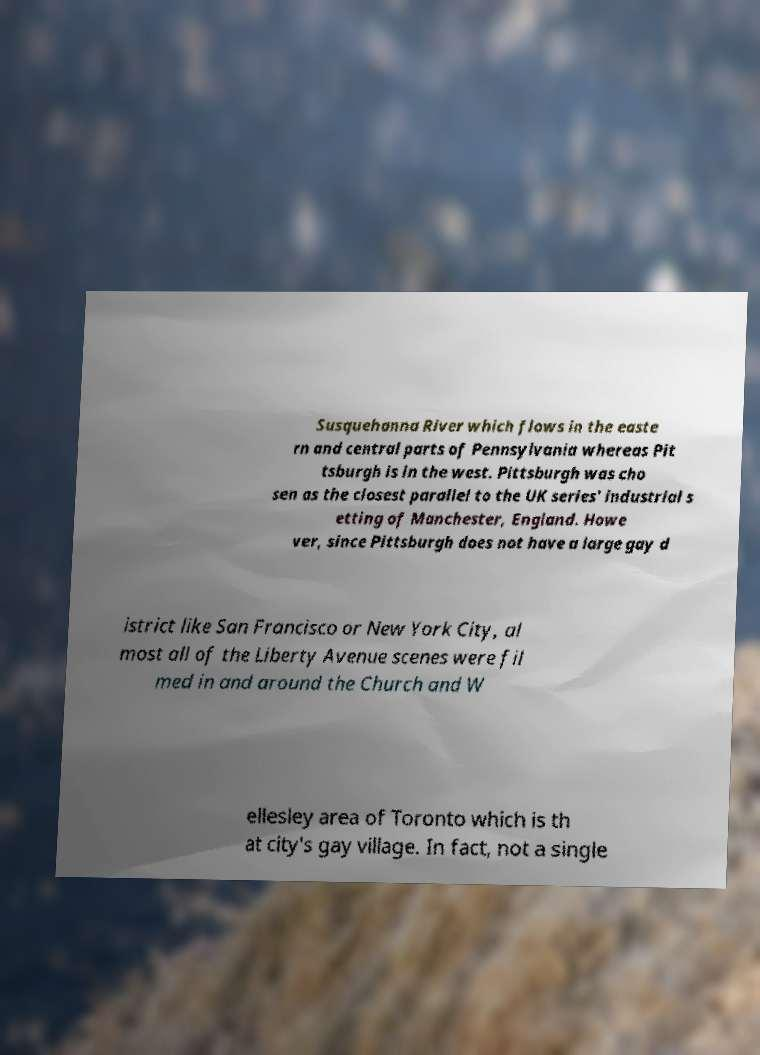Could you assist in decoding the text presented in this image and type it out clearly? Susquehanna River which flows in the easte rn and central parts of Pennsylvania whereas Pit tsburgh is in the west. Pittsburgh was cho sen as the closest parallel to the UK series' industrial s etting of Manchester, England. Howe ver, since Pittsburgh does not have a large gay d istrict like San Francisco or New York City, al most all of the Liberty Avenue scenes were fil med in and around the Church and W ellesley area of Toronto which is th at city's gay village. In fact, not a single 